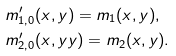<formula> <loc_0><loc_0><loc_500><loc_500>& m \rq _ { 1 , 0 } ( x , y ) = m _ { 1 } ( x , y ) , \\ & m \rq _ { 2 , 0 } ( x , y y ) = m _ { 2 } ( x , y ) .</formula> 